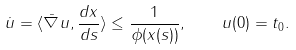Convert formula to latex. <formula><loc_0><loc_0><loc_500><loc_500>\dot { u } = \langle \bar { \nabla } u , \frac { d x } { d s } \rangle \leq \frac { 1 } { \phi ( x ( s ) ) } , \quad u ( 0 ) = t _ { 0 } .</formula> 